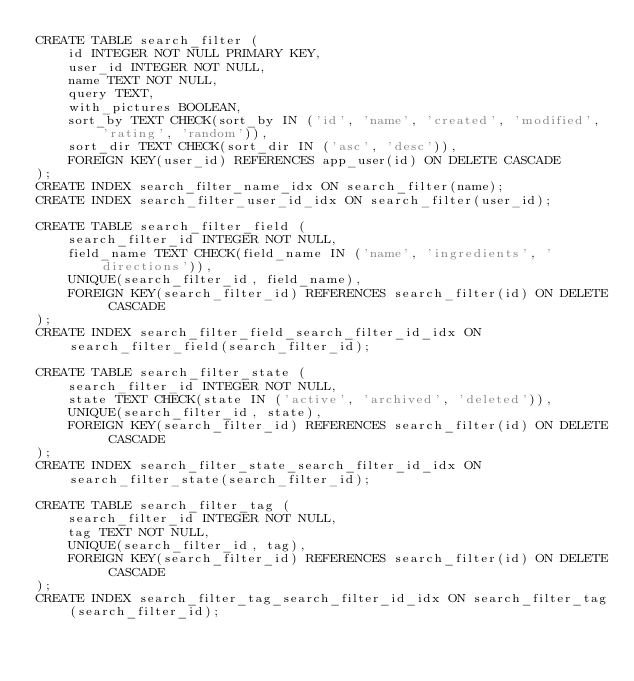<code> <loc_0><loc_0><loc_500><loc_500><_SQL_>CREATE TABLE search_filter (
    id INTEGER NOT NULL PRIMARY KEY,
    user_id INTEGER NOT NULL,
    name TEXT NOT NULL,
    query TEXT,
    with_pictures BOOLEAN,
    sort_by TEXT CHECK(sort_by IN ('id', 'name', 'created', 'modified', 'rating', 'random')),
    sort_dir TEXT CHECK(sort_dir IN ('asc', 'desc')),
    FOREIGN KEY(user_id) REFERENCES app_user(id) ON DELETE CASCADE
);
CREATE INDEX search_filter_name_idx ON search_filter(name);
CREATE INDEX search_filter_user_id_idx ON search_filter(user_id);

CREATE TABLE search_filter_field (
    search_filter_id INTEGER NOT NULL,
    field_name TEXT CHECK(field_name IN ('name', 'ingredients', 'directions')),
    UNIQUE(search_filter_id, field_name),
    FOREIGN KEY(search_filter_id) REFERENCES search_filter(id) ON DELETE CASCADE
);
CREATE INDEX search_filter_field_search_filter_id_idx ON search_filter_field(search_filter_id);

CREATE TABLE search_filter_state (
    search_filter_id INTEGER NOT NULL,
    state TEXT CHECK(state IN ('active', 'archived', 'deleted')),
    UNIQUE(search_filter_id, state),
    FOREIGN KEY(search_filter_id) REFERENCES search_filter(id) ON DELETE CASCADE
);
CREATE INDEX search_filter_state_search_filter_id_idx ON search_filter_state(search_filter_id);

CREATE TABLE search_filter_tag (
    search_filter_id INTEGER NOT NULL,
    tag TEXT NOT NULL,
    UNIQUE(search_filter_id, tag),
    FOREIGN KEY(search_filter_id) REFERENCES search_filter(id) ON DELETE CASCADE
);
CREATE INDEX search_filter_tag_search_filter_id_idx ON search_filter_tag(search_filter_id);
</code> 